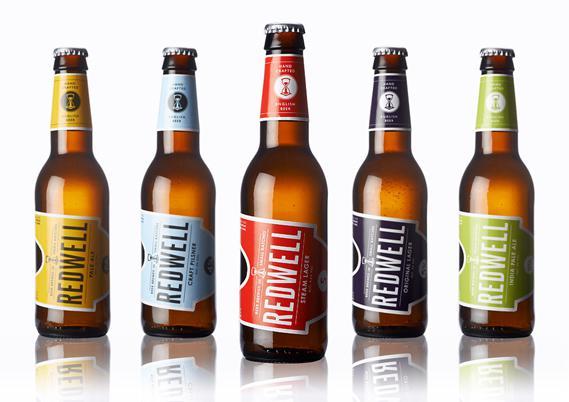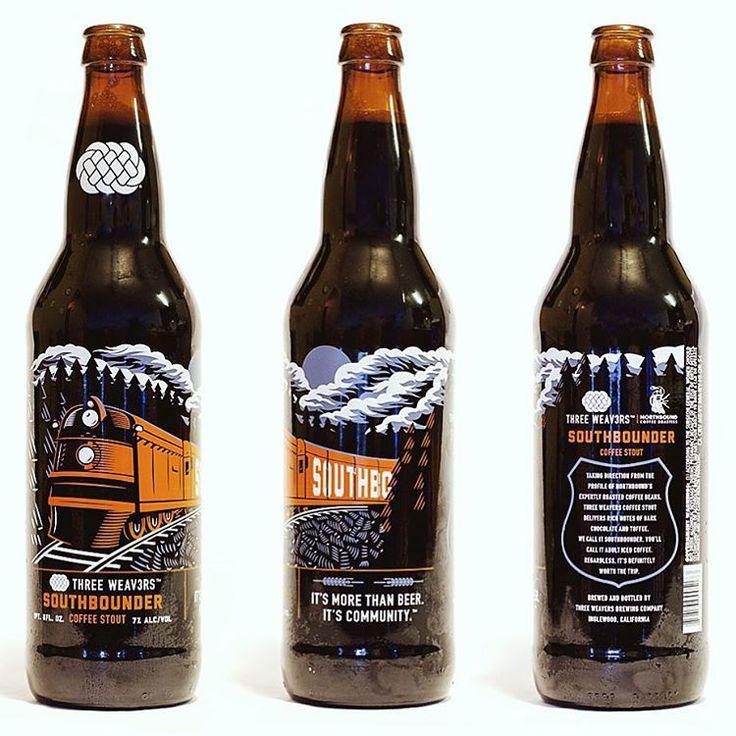The first image is the image on the left, the second image is the image on the right. For the images shown, is this caption "Each image contains exactly three bottles." true? Answer yes or no. No. The first image is the image on the left, the second image is the image on the right. For the images displayed, is the sentence "At least eight bottles of beer are shown." factually correct? Answer yes or no. Yes. 